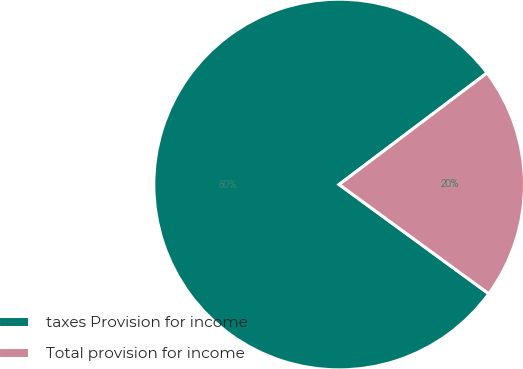Convert chart to OTSL. <chart><loc_0><loc_0><loc_500><loc_500><pie_chart><fcel>taxes Provision for income<fcel>Total provision for income<nl><fcel>79.68%<fcel>20.32%<nl></chart> 